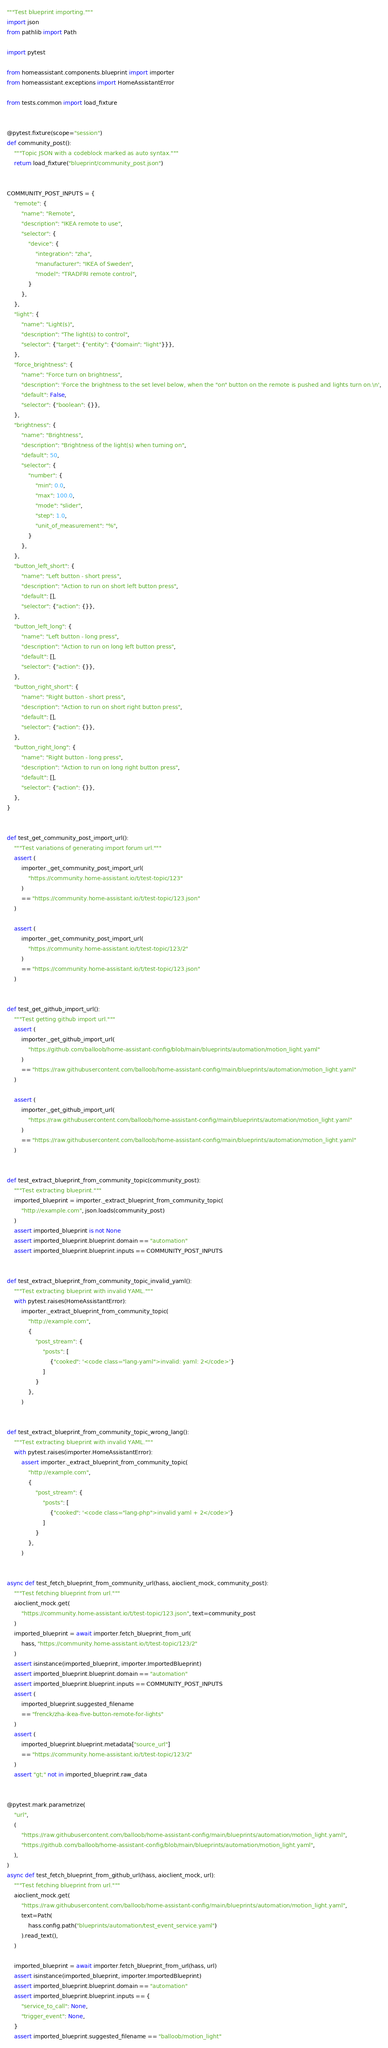<code> <loc_0><loc_0><loc_500><loc_500><_Python_>"""Test blueprint importing."""
import json
from pathlib import Path

import pytest

from homeassistant.components.blueprint import importer
from homeassistant.exceptions import HomeAssistantError

from tests.common import load_fixture


@pytest.fixture(scope="session")
def community_post():
    """Topic JSON with a codeblock marked as auto syntax."""
    return load_fixture("blueprint/community_post.json")


COMMUNITY_POST_INPUTS = {
    "remote": {
        "name": "Remote",
        "description": "IKEA remote to use",
        "selector": {
            "device": {
                "integration": "zha",
                "manufacturer": "IKEA of Sweden",
                "model": "TRADFRI remote control",
            }
        },
    },
    "light": {
        "name": "Light(s)",
        "description": "The light(s) to control",
        "selector": {"target": {"entity": {"domain": "light"}}},
    },
    "force_brightness": {
        "name": "Force turn on brightness",
        "description": 'Force the brightness to the set level below, when the "on" button on the remote is pushed and lights turn on.\n',
        "default": False,
        "selector": {"boolean": {}},
    },
    "brightness": {
        "name": "Brightness",
        "description": "Brightness of the light(s) when turning on",
        "default": 50,
        "selector": {
            "number": {
                "min": 0.0,
                "max": 100.0,
                "mode": "slider",
                "step": 1.0,
                "unit_of_measurement": "%",
            }
        },
    },
    "button_left_short": {
        "name": "Left button - short press",
        "description": "Action to run on short left button press",
        "default": [],
        "selector": {"action": {}},
    },
    "button_left_long": {
        "name": "Left button - long press",
        "description": "Action to run on long left button press",
        "default": [],
        "selector": {"action": {}},
    },
    "button_right_short": {
        "name": "Right button - short press",
        "description": "Action to run on short right button press",
        "default": [],
        "selector": {"action": {}},
    },
    "button_right_long": {
        "name": "Right button - long press",
        "description": "Action to run on long right button press",
        "default": [],
        "selector": {"action": {}},
    },
}


def test_get_community_post_import_url():
    """Test variations of generating import forum url."""
    assert (
        importer._get_community_post_import_url(
            "https://community.home-assistant.io/t/test-topic/123"
        )
        == "https://community.home-assistant.io/t/test-topic/123.json"
    )

    assert (
        importer._get_community_post_import_url(
            "https://community.home-assistant.io/t/test-topic/123/2"
        )
        == "https://community.home-assistant.io/t/test-topic/123.json"
    )


def test_get_github_import_url():
    """Test getting github import url."""
    assert (
        importer._get_github_import_url(
            "https://github.com/balloob/home-assistant-config/blob/main/blueprints/automation/motion_light.yaml"
        )
        == "https://raw.githubusercontent.com/balloob/home-assistant-config/main/blueprints/automation/motion_light.yaml"
    )

    assert (
        importer._get_github_import_url(
            "https://raw.githubusercontent.com/balloob/home-assistant-config/main/blueprints/automation/motion_light.yaml"
        )
        == "https://raw.githubusercontent.com/balloob/home-assistant-config/main/blueprints/automation/motion_light.yaml"
    )


def test_extract_blueprint_from_community_topic(community_post):
    """Test extracting blueprint."""
    imported_blueprint = importer._extract_blueprint_from_community_topic(
        "http://example.com", json.loads(community_post)
    )
    assert imported_blueprint is not None
    assert imported_blueprint.blueprint.domain == "automation"
    assert imported_blueprint.blueprint.inputs == COMMUNITY_POST_INPUTS


def test_extract_blueprint_from_community_topic_invalid_yaml():
    """Test extracting blueprint with invalid YAML."""
    with pytest.raises(HomeAssistantError):
        importer._extract_blueprint_from_community_topic(
            "http://example.com",
            {
                "post_stream": {
                    "posts": [
                        {"cooked": '<code class="lang-yaml">invalid: yaml: 2</code>'}
                    ]
                }
            },
        )


def test_extract_blueprint_from_community_topic_wrong_lang():
    """Test extracting blueprint with invalid YAML."""
    with pytest.raises(importer.HomeAssistantError):
        assert importer._extract_blueprint_from_community_topic(
            "http://example.com",
            {
                "post_stream": {
                    "posts": [
                        {"cooked": '<code class="lang-php">invalid yaml + 2</code>'}
                    ]
                }
            },
        )


async def test_fetch_blueprint_from_community_url(hass, aioclient_mock, community_post):
    """Test fetching blueprint from url."""
    aioclient_mock.get(
        "https://community.home-assistant.io/t/test-topic/123.json", text=community_post
    )
    imported_blueprint = await importer.fetch_blueprint_from_url(
        hass, "https://community.home-assistant.io/t/test-topic/123/2"
    )
    assert isinstance(imported_blueprint, importer.ImportedBlueprint)
    assert imported_blueprint.blueprint.domain == "automation"
    assert imported_blueprint.blueprint.inputs == COMMUNITY_POST_INPUTS
    assert (
        imported_blueprint.suggested_filename
        == "frenck/zha-ikea-five-button-remote-for-lights"
    )
    assert (
        imported_blueprint.blueprint.metadata["source_url"]
        == "https://community.home-assistant.io/t/test-topic/123/2"
    )
    assert "gt;" not in imported_blueprint.raw_data


@pytest.mark.parametrize(
    "url",
    (
        "https://raw.githubusercontent.com/balloob/home-assistant-config/main/blueprints/automation/motion_light.yaml",
        "https://github.com/balloob/home-assistant-config/blob/main/blueprints/automation/motion_light.yaml",
    ),
)
async def test_fetch_blueprint_from_github_url(hass, aioclient_mock, url):
    """Test fetching blueprint from url."""
    aioclient_mock.get(
        "https://raw.githubusercontent.com/balloob/home-assistant-config/main/blueprints/automation/motion_light.yaml",
        text=Path(
            hass.config.path("blueprints/automation/test_event_service.yaml")
        ).read_text(),
    )

    imported_blueprint = await importer.fetch_blueprint_from_url(hass, url)
    assert isinstance(imported_blueprint, importer.ImportedBlueprint)
    assert imported_blueprint.blueprint.domain == "automation"
    assert imported_blueprint.blueprint.inputs == {
        "service_to_call": None,
        "trigger_event": None,
    }
    assert imported_blueprint.suggested_filename == "balloob/motion_light"</code> 